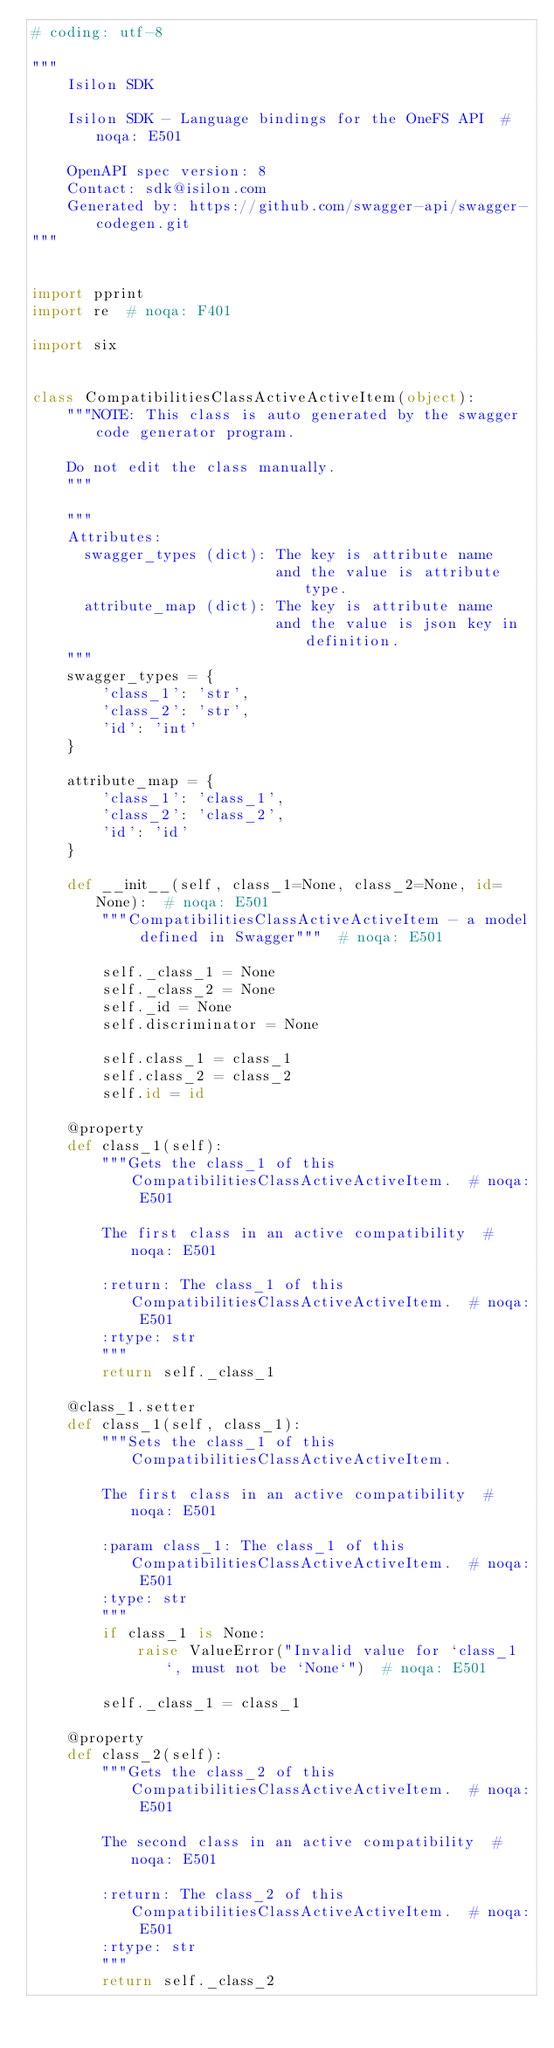<code> <loc_0><loc_0><loc_500><loc_500><_Python_># coding: utf-8

"""
    Isilon SDK

    Isilon SDK - Language bindings for the OneFS API  # noqa: E501

    OpenAPI spec version: 8
    Contact: sdk@isilon.com
    Generated by: https://github.com/swagger-api/swagger-codegen.git
"""


import pprint
import re  # noqa: F401

import six


class CompatibilitiesClassActiveActiveItem(object):
    """NOTE: This class is auto generated by the swagger code generator program.

    Do not edit the class manually.
    """

    """
    Attributes:
      swagger_types (dict): The key is attribute name
                            and the value is attribute type.
      attribute_map (dict): The key is attribute name
                            and the value is json key in definition.
    """
    swagger_types = {
        'class_1': 'str',
        'class_2': 'str',
        'id': 'int'
    }

    attribute_map = {
        'class_1': 'class_1',
        'class_2': 'class_2',
        'id': 'id'
    }

    def __init__(self, class_1=None, class_2=None, id=None):  # noqa: E501
        """CompatibilitiesClassActiveActiveItem - a model defined in Swagger"""  # noqa: E501

        self._class_1 = None
        self._class_2 = None
        self._id = None
        self.discriminator = None

        self.class_1 = class_1
        self.class_2 = class_2
        self.id = id

    @property
    def class_1(self):
        """Gets the class_1 of this CompatibilitiesClassActiveActiveItem.  # noqa: E501

        The first class in an active compatibility  # noqa: E501

        :return: The class_1 of this CompatibilitiesClassActiveActiveItem.  # noqa: E501
        :rtype: str
        """
        return self._class_1

    @class_1.setter
    def class_1(self, class_1):
        """Sets the class_1 of this CompatibilitiesClassActiveActiveItem.

        The first class in an active compatibility  # noqa: E501

        :param class_1: The class_1 of this CompatibilitiesClassActiveActiveItem.  # noqa: E501
        :type: str
        """
        if class_1 is None:
            raise ValueError("Invalid value for `class_1`, must not be `None`")  # noqa: E501

        self._class_1 = class_1

    @property
    def class_2(self):
        """Gets the class_2 of this CompatibilitiesClassActiveActiveItem.  # noqa: E501

        The second class in an active compatibility  # noqa: E501

        :return: The class_2 of this CompatibilitiesClassActiveActiveItem.  # noqa: E501
        :rtype: str
        """
        return self._class_2
</code> 